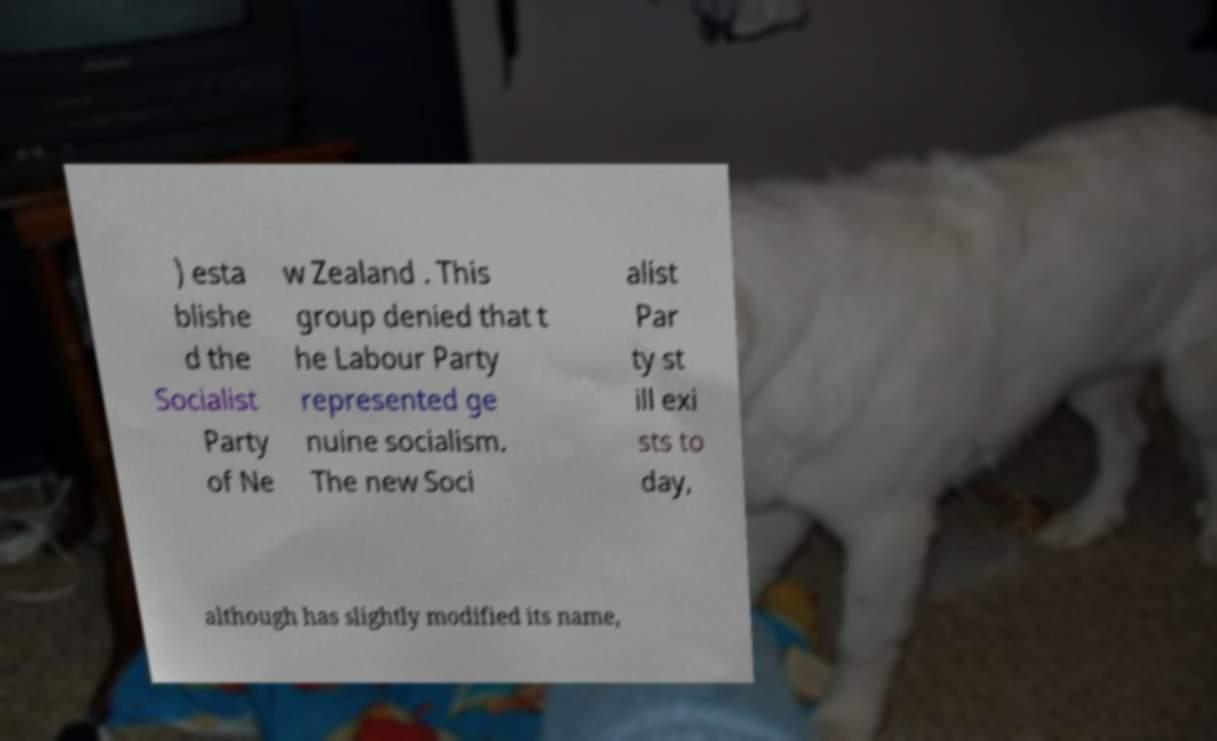Can you accurately transcribe the text from the provided image for me? ) esta blishe d the Socialist Party of Ne w Zealand . This group denied that t he Labour Party represented ge nuine socialism. The new Soci alist Par ty st ill exi sts to day, although has slightly modified its name, 